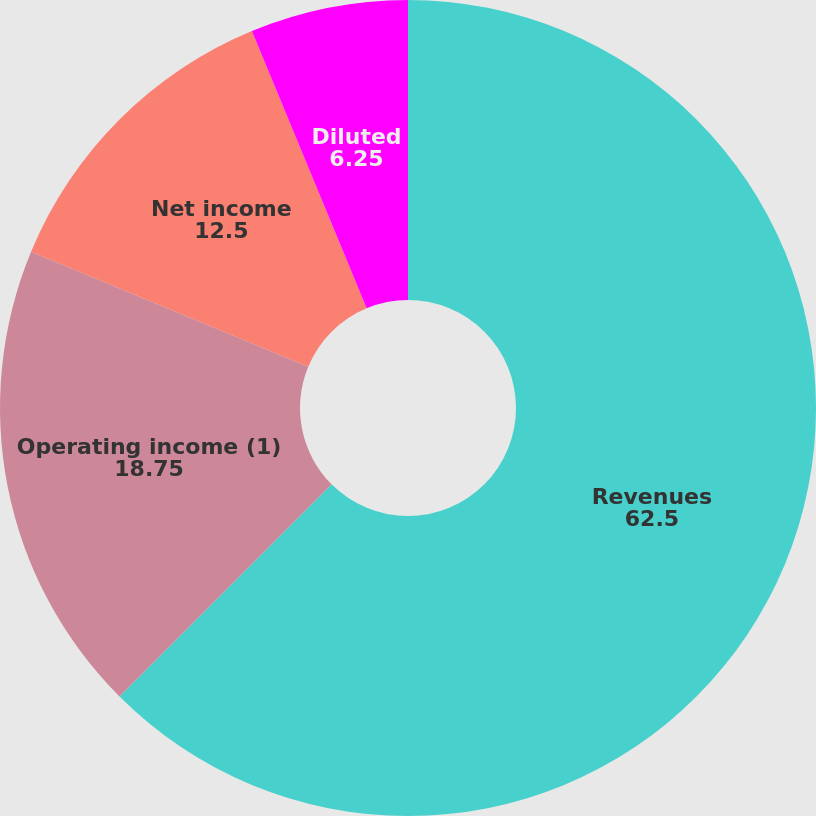Convert chart. <chart><loc_0><loc_0><loc_500><loc_500><pie_chart><fcel>Revenues<fcel>Operating income (1)<fcel>Net income<fcel>Basic<fcel>Diluted<nl><fcel>62.5%<fcel>18.75%<fcel>12.5%<fcel>0.0%<fcel>6.25%<nl></chart> 